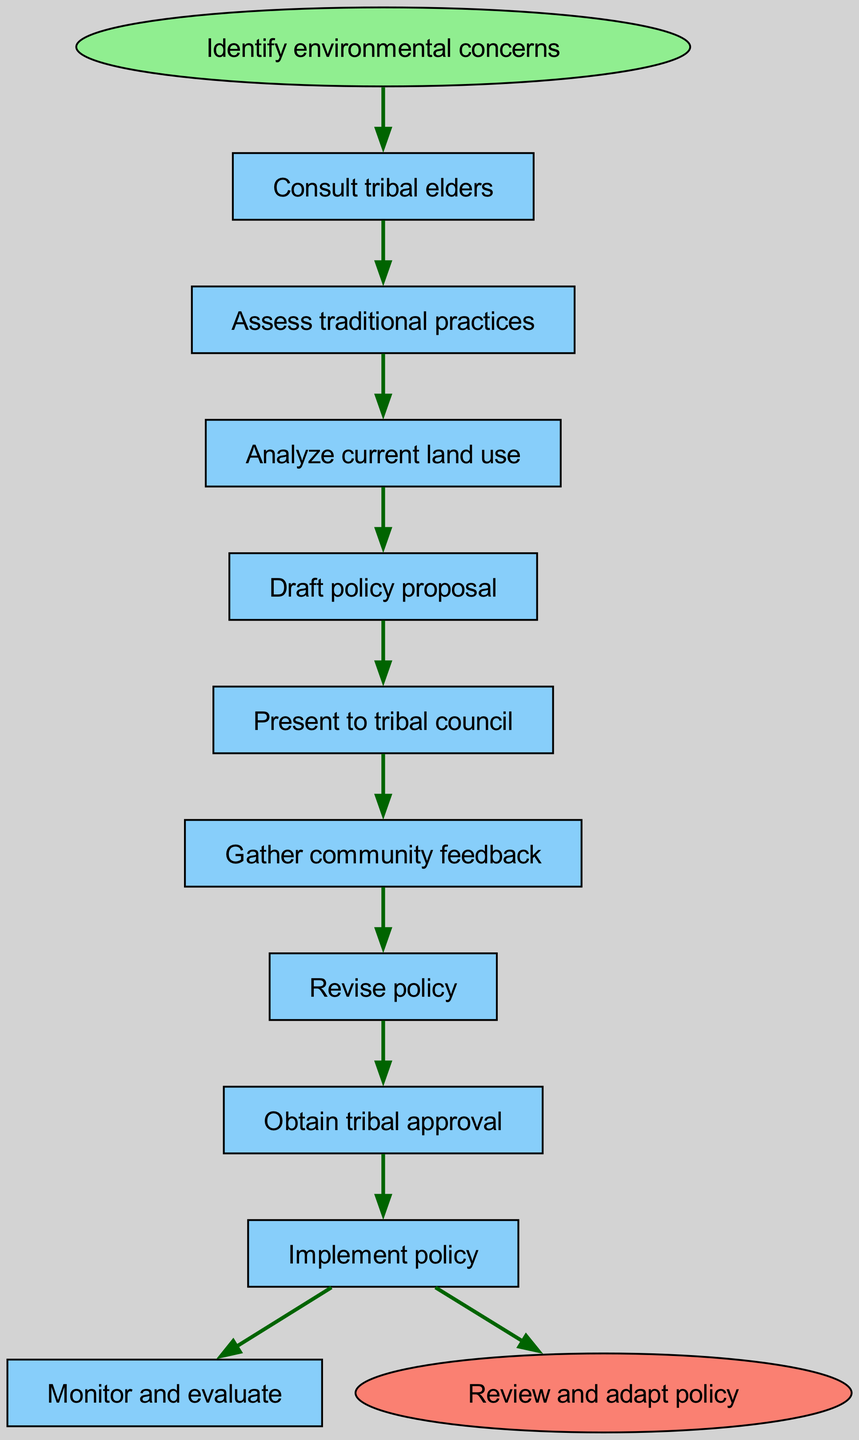What is the starting point of the diagram? The starting point, indicated by the node labeled "Identify environmental concerns," is the first step in the flow chart, leading into the subsequent actions.
Answer: Identify environmental concerns What is the last step before the policy is reviewed? The last step before the review and adaptation is the "Implement policy," which connects directly to the end node of the diagram.
Answer: Implement policy How many steps are there in total? Counting from the initial identification of concerns through to obtaining tribal approval, there are a total of 9 distinct steps in the process, including the final review.
Answer: 9 Which step directly follows "Draft policy proposal"? The step that directly follows "Draft policy proposal" is "Present to tribal council," based on the flow indicated in the diagram.
Answer: Present to tribal council What is the relationship between "Gather community feedback" and "Revise policy"? The relationship is sequential; "Gather community feedback" leads directly into "Revise policy," indicating that community input is essential for making modifications to the initial proposal.
Answer: Sequential What are the steps before obtaining tribal approval? Before obtaining tribal approval, the steps to complete are "Revise policy" and "Gather community feedback," which are necessary for finalizing the policy prior to approval.
Answer: Revise policy, Gather community feedback Which step involves consultation with tribal elders? The step that involves consultation with tribal elders is "Consult tribal elders," which takes place immediately after identifying environmental concerns in the flow.
Answer: Consult tribal elders What is one of the key actions before implementing the policy? One of the key actions before implementing the policy is "Obtain tribal approval," which is necessary to ensure that the policy is accepted and supported by the tribe.
Answer: Obtain tribal approval Describe the flow from analyzing current land use to drafting a policy proposal. The flow starts from "Analyze current land use," which feeds into "Draft policy proposal," indicating that understanding current practices is crucial before creating a formal policy document.
Answer: Analyze current land use to Draft policy proposal 